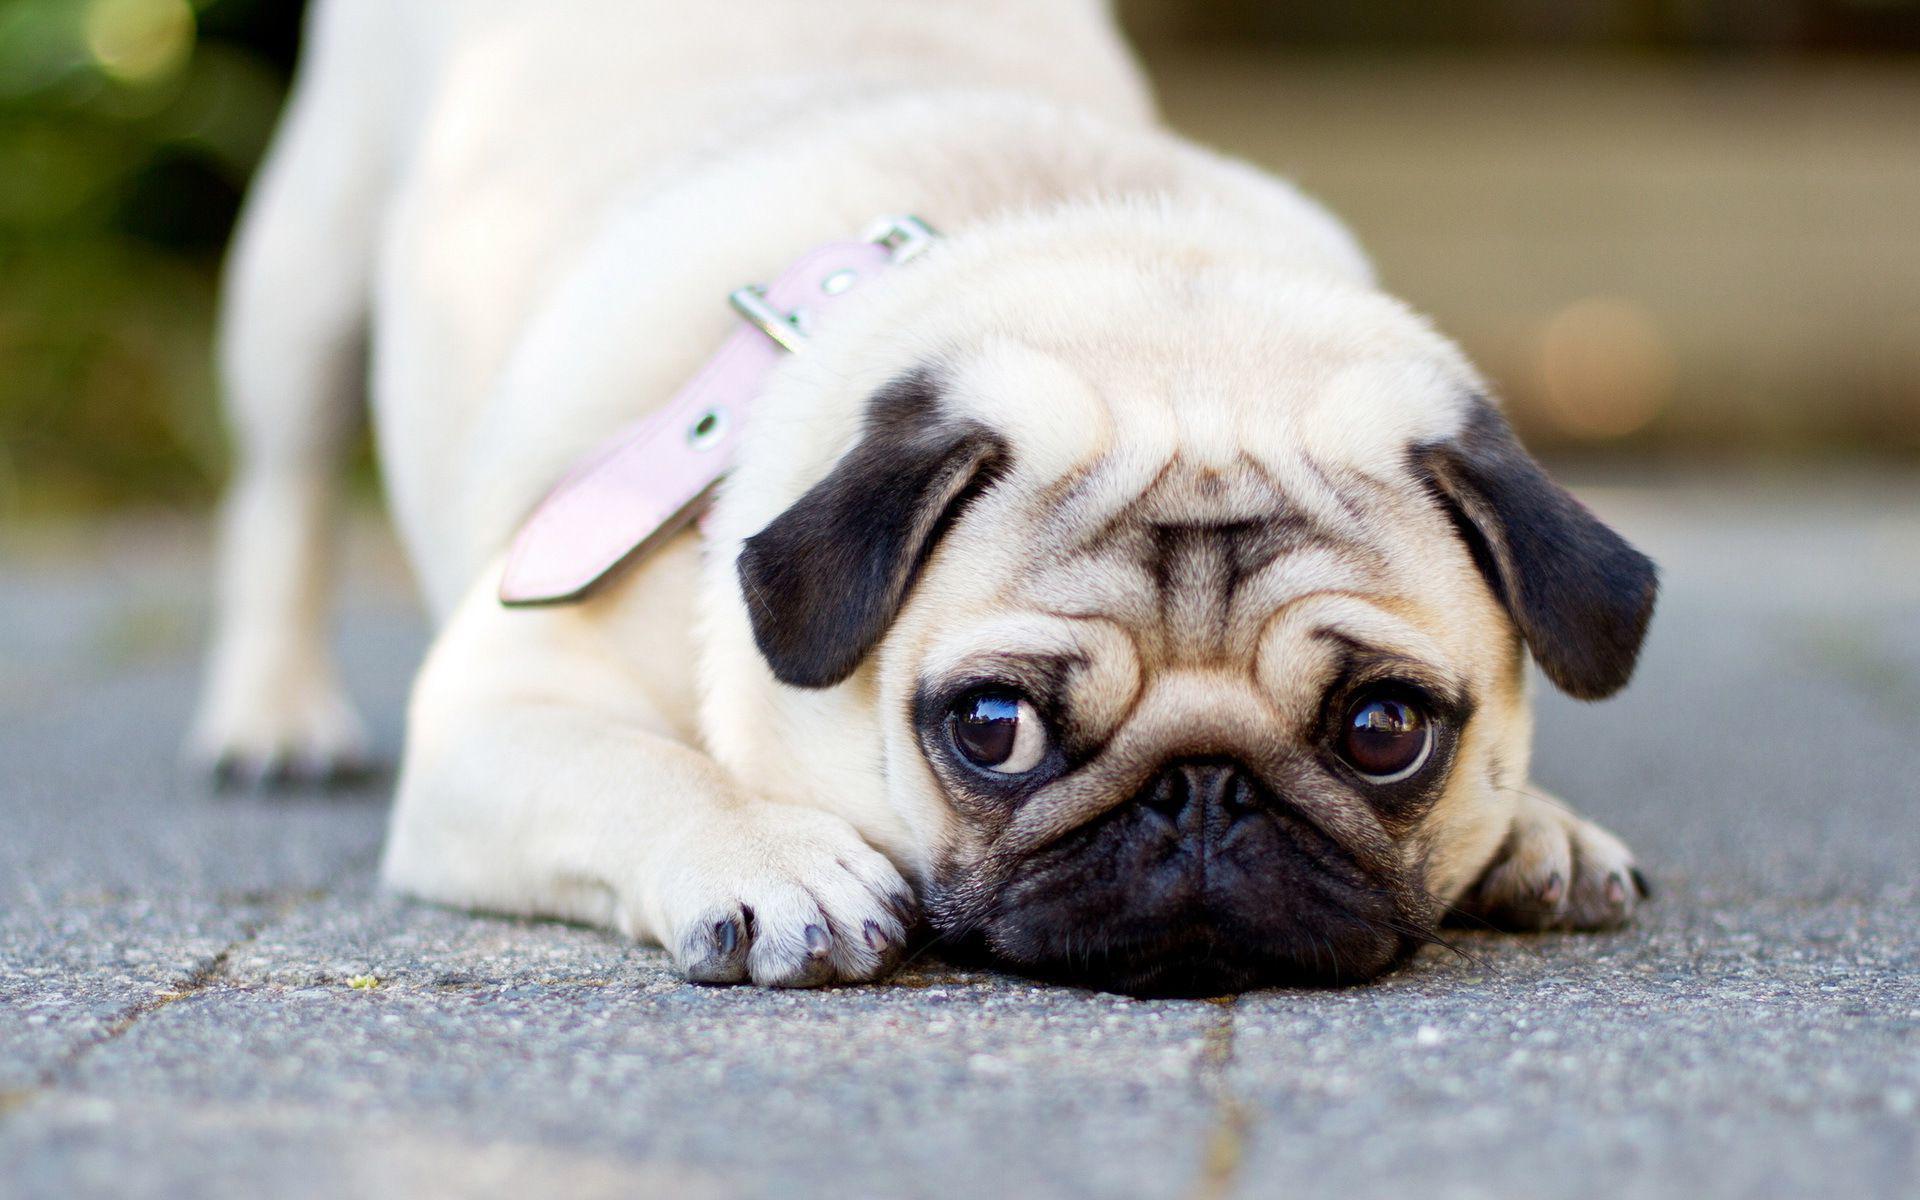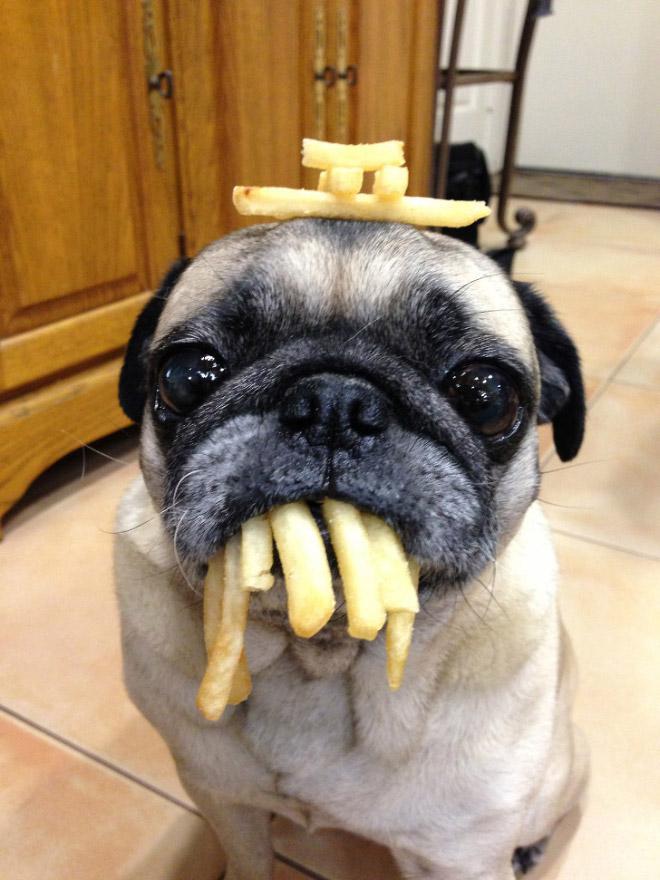The first image is the image on the left, the second image is the image on the right. Analyze the images presented: Is the assertion "One image shows a camera-facing sitting pug with something bright blue hanging downward from its neck." valid? Answer yes or no. No. 